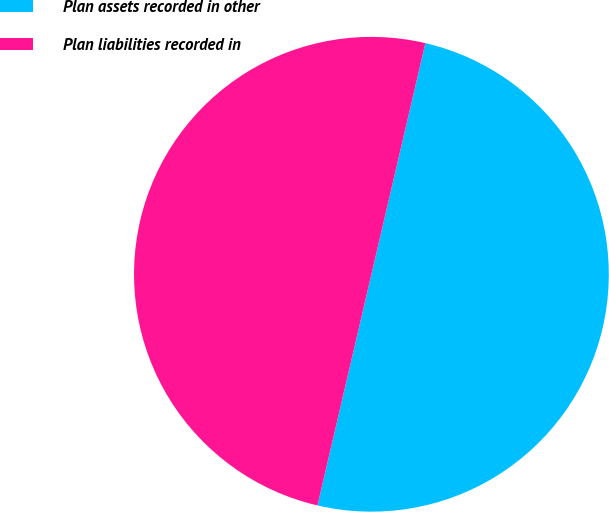Convert chart. <chart><loc_0><loc_0><loc_500><loc_500><pie_chart><fcel>Plan assets recorded in other<fcel>Plan liabilities recorded in<nl><fcel>50.0%<fcel>50.0%<nl></chart> 